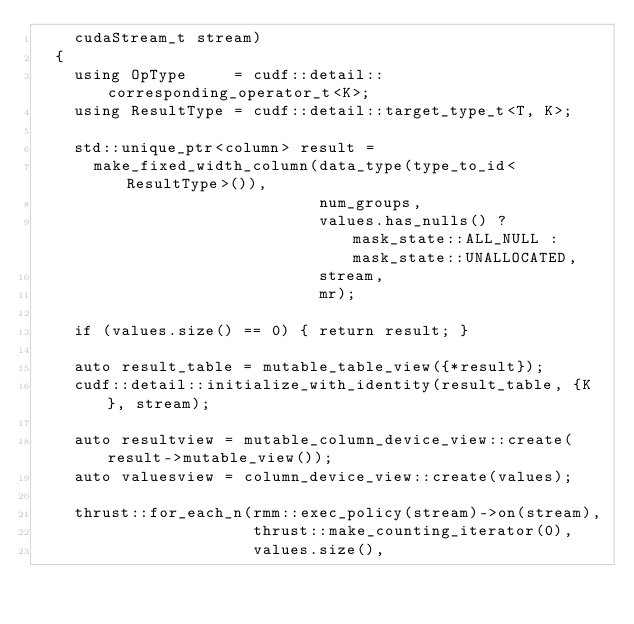<code> <loc_0><loc_0><loc_500><loc_500><_Cuda_>    cudaStream_t stream)
  {
    using OpType     = cudf::detail::corresponding_operator_t<K>;
    using ResultType = cudf::detail::target_type_t<T, K>;

    std::unique_ptr<column> result =
      make_fixed_width_column(data_type(type_to_id<ResultType>()),
                              num_groups,
                              values.has_nulls() ? mask_state::ALL_NULL : mask_state::UNALLOCATED,
                              stream,
                              mr);

    if (values.size() == 0) { return result; }

    auto result_table = mutable_table_view({*result});
    cudf::detail::initialize_with_identity(result_table, {K}, stream);

    auto resultview = mutable_column_device_view::create(result->mutable_view());
    auto valuesview = column_device_view::create(values);

    thrust::for_each_n(rmm::exec_policy(stream)->on(stream),
                       thrust::make_counting_iterator(0),
                       values.size(),</code> 